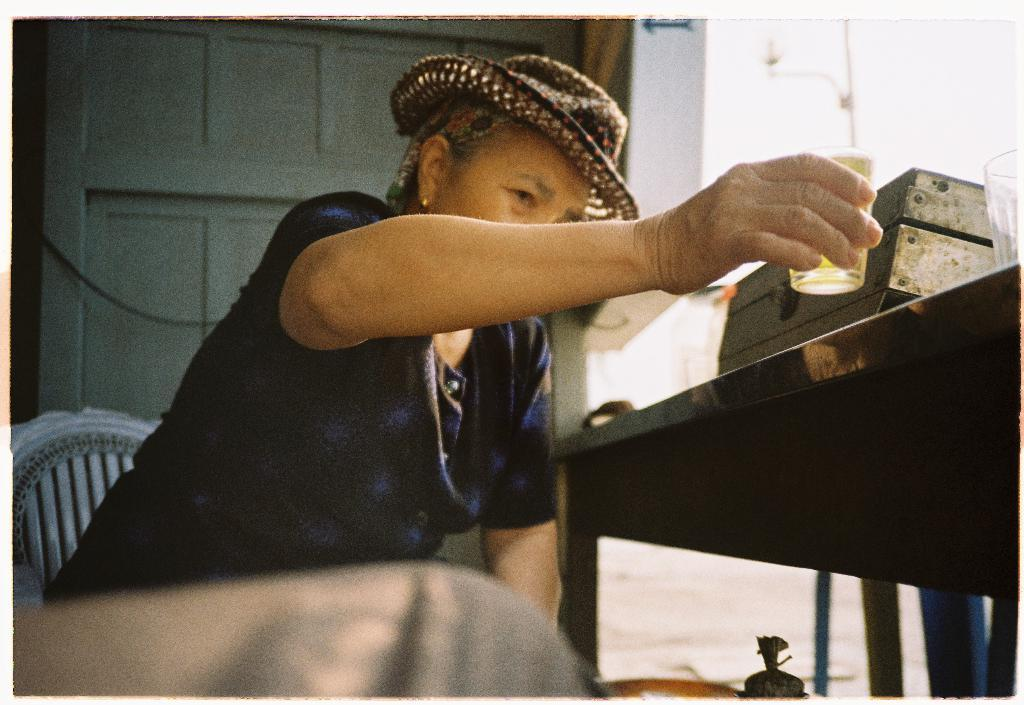What is the person in the image doing? The person is sitting on a chair in the image. What is the person holding in the image? The person is holding a glass in the image. What accessory is the person wearing in the image? The person is wearing a hat in the image. What piece of furniture is present in the image? There is a table in the image. What else can be seen on the table in the image? There is another glass and a box on the table in the image. What type of glue is the person using to stick the parent to the wish in the image? There is no glue, parent, or wish present in the image. 